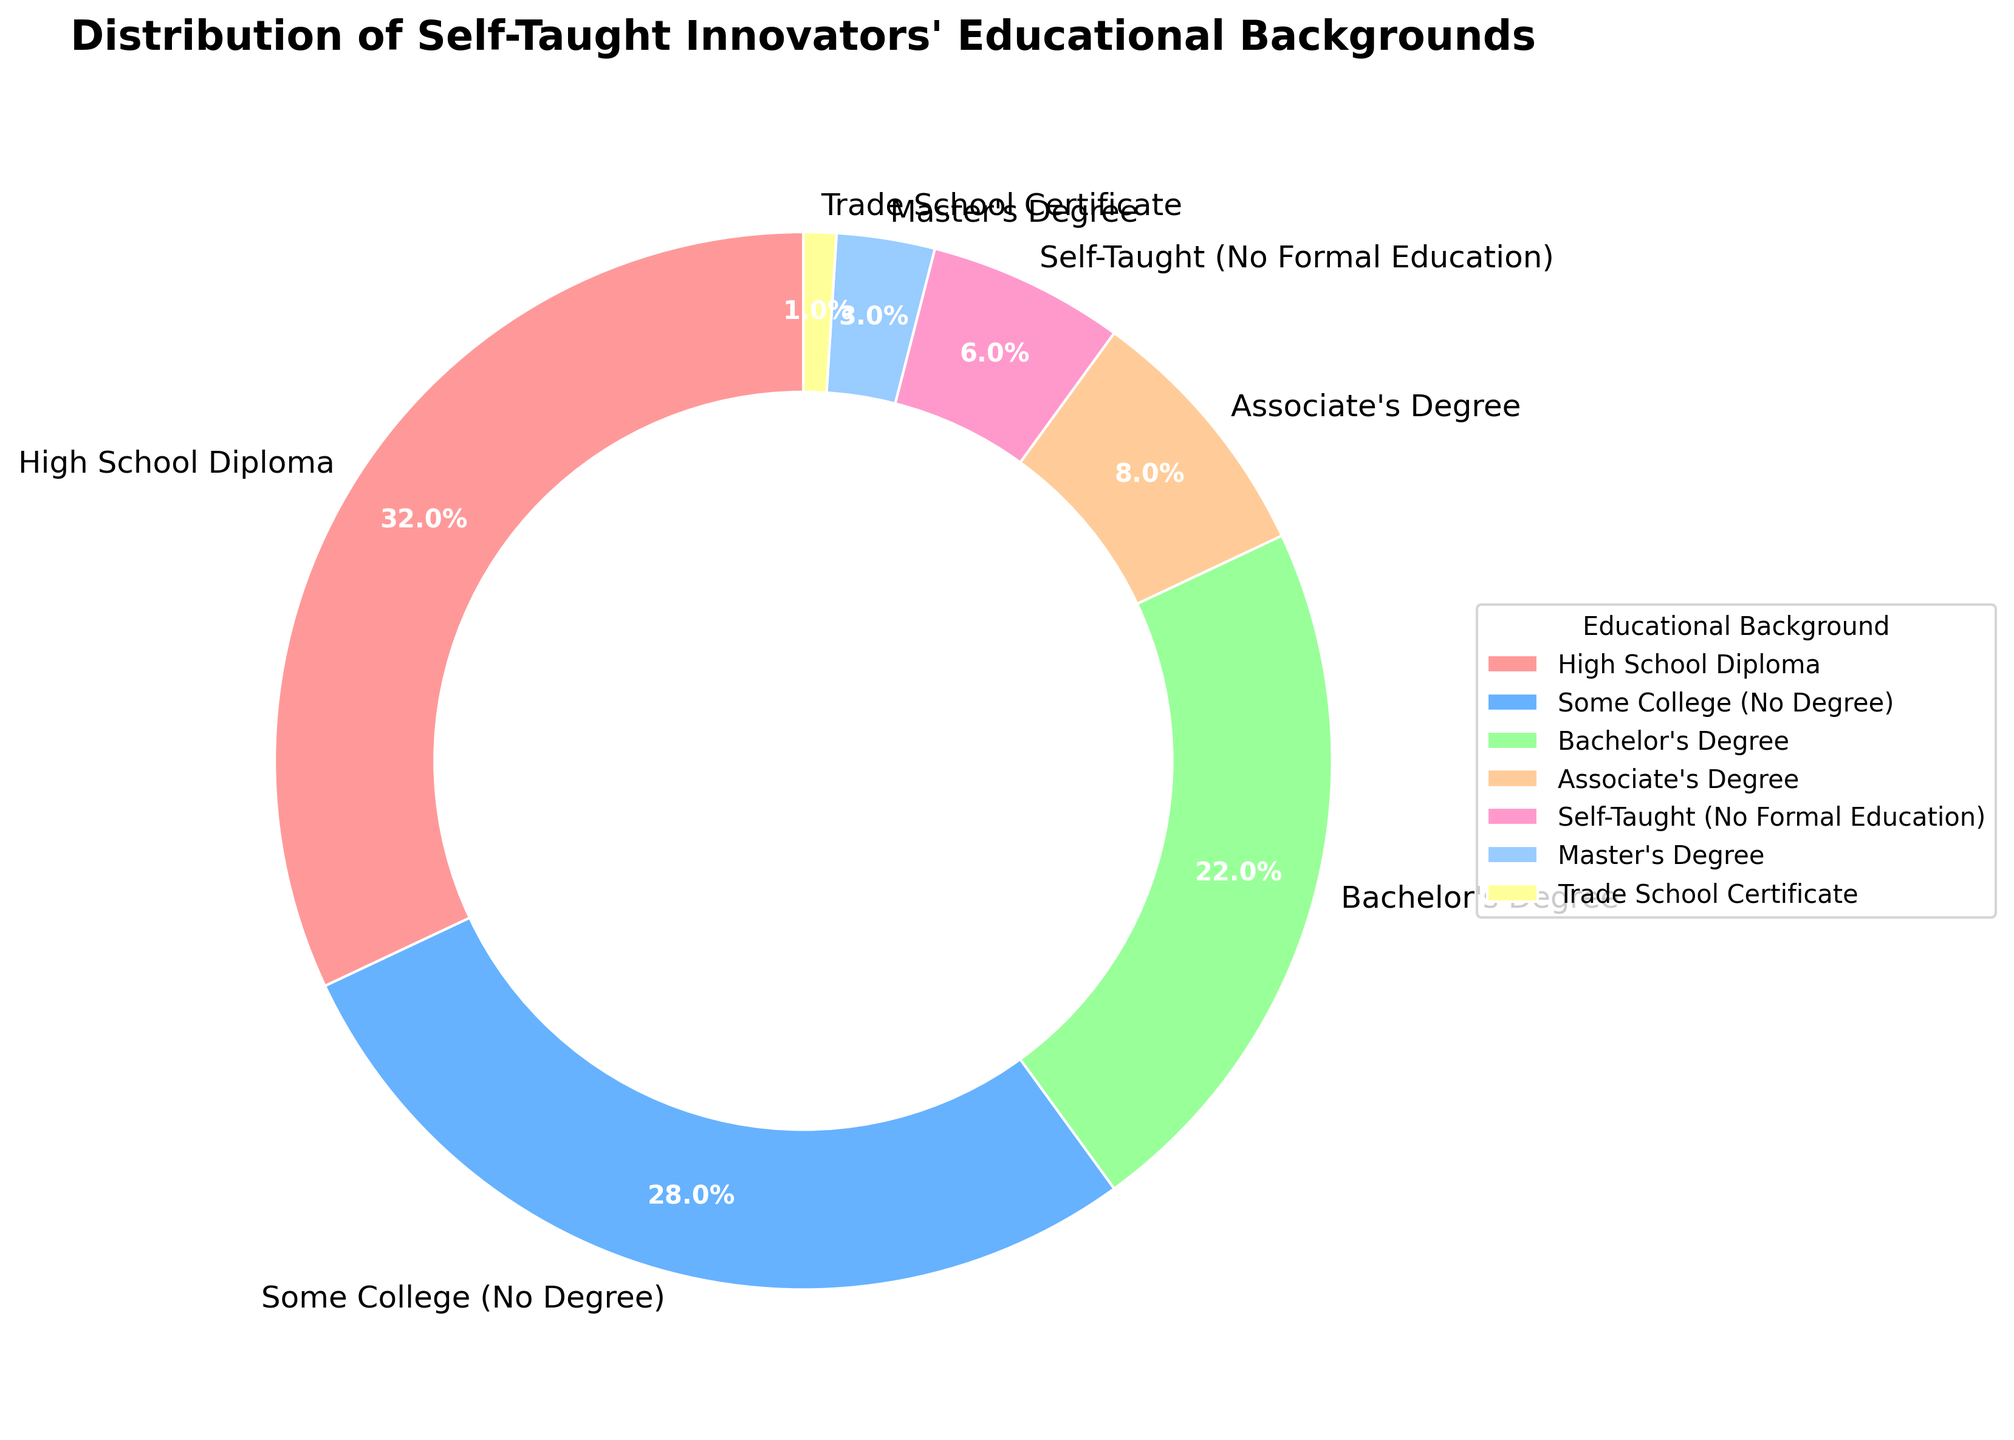How many educational backgrounds have a representation greater than 20% in the chart? Identify the percentages of each educational background from the chart. High School Diploma (32%), Some College (28%), and Bachelor's Degree (22%) are all greater than 20%. There are 3 such backgrounds in total.
Answer: 3 Which educational background has the smallest representation in the pie chart? Examine each segment along with their corresponding labels and percentages. Trade School Certificate has the smallest representation at 1%.
Answer: Trade School Certificate What is the combined percentage of High School Diploma and Bachelor's Degree in the pie chart? Add the percentages of High School Diploma (32%) and Bachelor's Degree (22%). The total is 32% + 22% = 54%.
Answer: 54% Is the representation of Some College (No Degree) more or less than double the representation of Associate's Degree? Compare the percentages: Some College (No Degree) is 28%, and Associate's Degree is 8%. Double of Associate's Degree would be 8% * 2 = 16%. Since 28% (Some College) is greater than 16% (double of Associate's Degree), it's more.
Answer: More What is the difference in percentage between the highest and the lowest represented educational backgrounds? Identify the highest and lowest values from the chart: Highest is High School Diploma (32%), and lowest is Trade School Certificate (1%). Calculate the difference: 32% - 1% = 31%.
Answer: 31% Which two educational backgrounds together make up nearly the same percentage as High School Diploma alone? High School Diploma alone is 32%. Let's find two values that sum close to 32%. Some College (28%) + Self-Taught (6%) = 28% + 6% = 34%, which is the closest match.
Answer: Some College and Self-Taught What portion of self-taught innovators have a formal college degree, including Associate, Bachelor’s, and Master’s Degrees? Summing the percentages of Associate's (8%), Bachelor's (22%), and Master's (3%) gives us: 8% + 22% + 3% = 33%.
Answer: 33% Between Self-Taught (No Formal Education) and Associate's Degree, which has the higher representation and by how much? Compare percentages: Self-Taught (6%) and Associate's Degree (8%). Associate's Degree is higher, and the difference is 8% - 6% = 2%.
Answer: Associate's Degree by 2% How much more representation does Some College (No Degree) have compared to Self-Taught (No Formal Education)? Compare the two percentages: Some College (28%) and Self-Taught (6%). The difference is 28% - 6% = 22%.
Answer: 22% What percentage of self-taught innovators have education levels below a Bachelor's Degree (excluding Self-Taught)? Summing percentages for High School Diploma (32%), Some College (28%), Associate's Degree (8%), and Trade School Certificate (1%): 32% + 28% + 8% + 1% = 69%.
Answer: 69% 